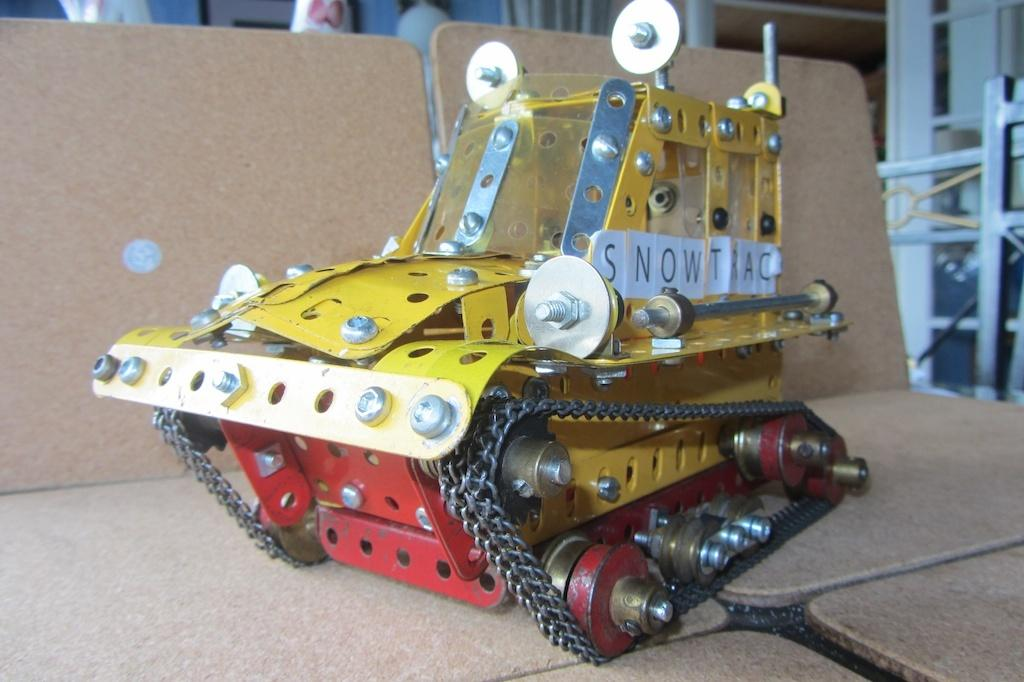What is the main object in the foreground of the image? There is an object on a table in the foreground of the image. What can be seen in the background of the image? There are metal rods in the background of the image. Can you determine the time of day the image was taken? The image was likely taken during the day, as there is no indication of darkness or artificial lighting. How many toes can be seen on the representative in the image? There is no representative present in the image, and therefore no toes can be seen. 